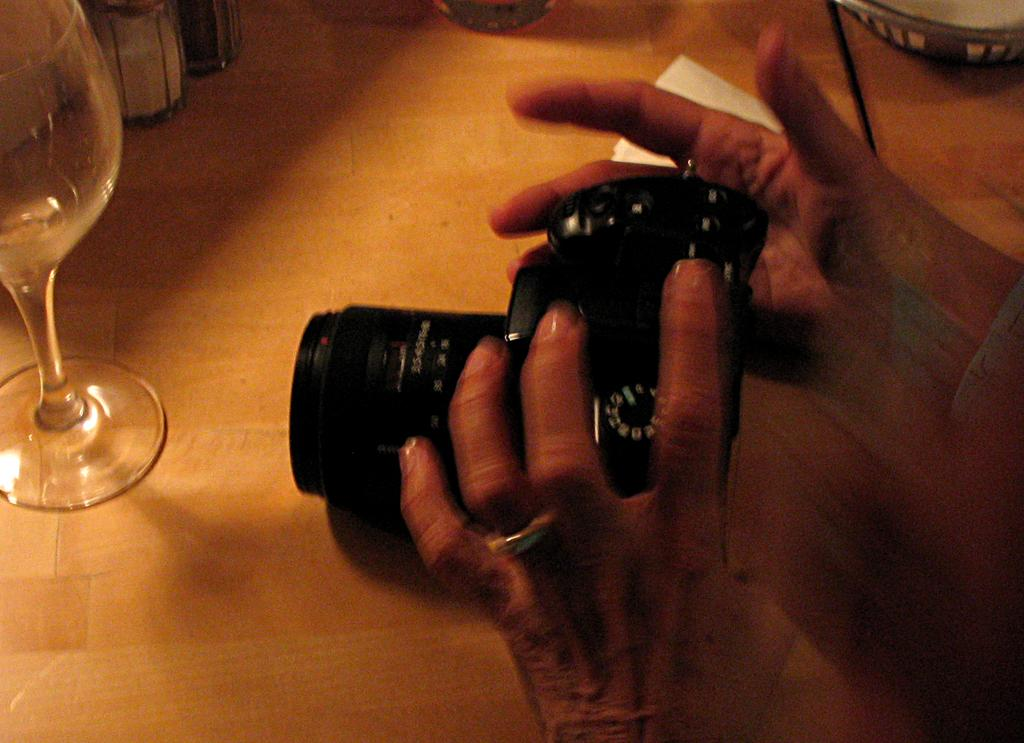What is being held by the human hands in the image? Human hands are holding a camera in the image. What type of surface can be seen in the image? There is a wooden surface in the image. What type of glassware is visible in the image? A wine glass is visible in the image. What additional object can be seen in the image? A cable wire is present in the image. What type of truck is visible in the image? There is no truck present in the image. What button is being pressed by the hands in the image? The hands in the image are holding a camera, not pressing any buttons. 